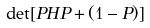Convert formula to latex. <formula><loc_0><loc_0><loc_500><loc_500>\det [ P H P + ( 1 - P ) ]</formula> 